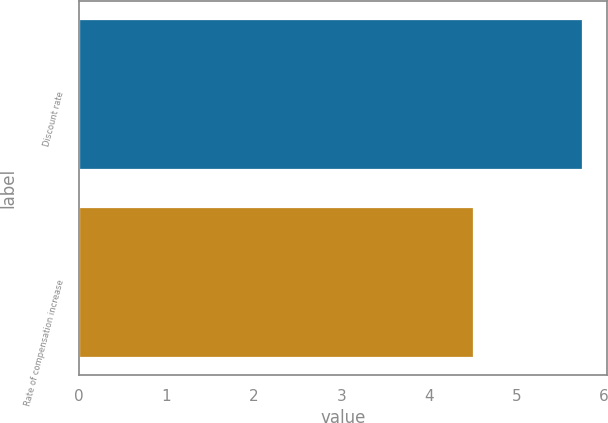<chart> <loc_0><loc_0><loc_500><loc_500><bar_chart><fcel>Discount rate<fcel>Rate of compensation increase<nl><fcel>5.75<fcel>4.5<nl></chart> 